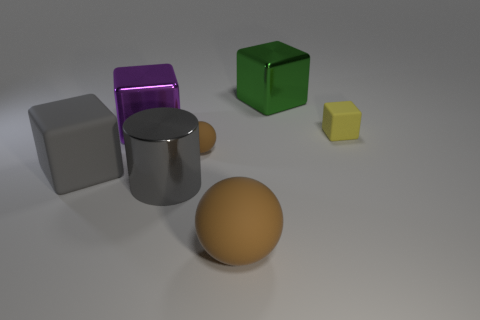What can you infer about the materials of the objects based on their appearance? Based on the image, we can speculate about the materials of the objects. The large green cube and the small yellow cube have surfaces that appear smooth and possibly plastic. The big metal cube has a matte surface, which suggests it could be made of painted metal. The large purple cube has a slightly reflective and translucent surface, indicating it could be made of glass or a similar material. Furthermore, the mid-sized sphere has a dull surface that might be made of a matte material like clay or rubber. 